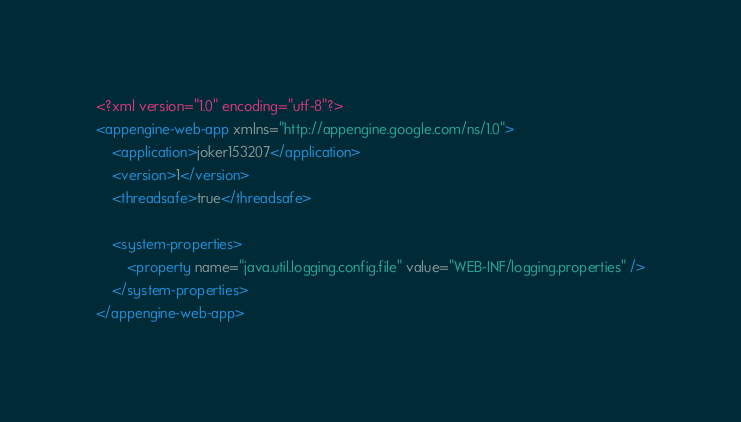<code> <loc_0><loc_0><loc_500><loc_500><_XML_><?xml version="1.0" encoding="utf-8"?>
<appengine-web-app xmlns="http://appengine.google.com/ns/1.0">
    <application>joker153207</application>
    <version>1</version>
    <threadsafe>true</threadsafe>

    <system-properties>
        <property name="java.util.logging.config.file" value="WEB-INF/logging.properties" />
    </system-properties>
</appengine-web-app></code> 